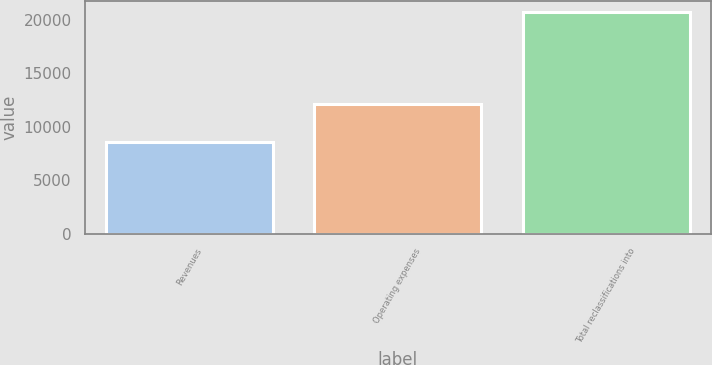Convert chart to OTSL. <chart><loc_0><loc_0><loc_500><loc_500><bar_chart><fcel>Revenues<fcel>Operating expenses<fcel>Total reclassifications into<nl><fcel>8585<fcel>12125<fcel>20692<nl></chart> 